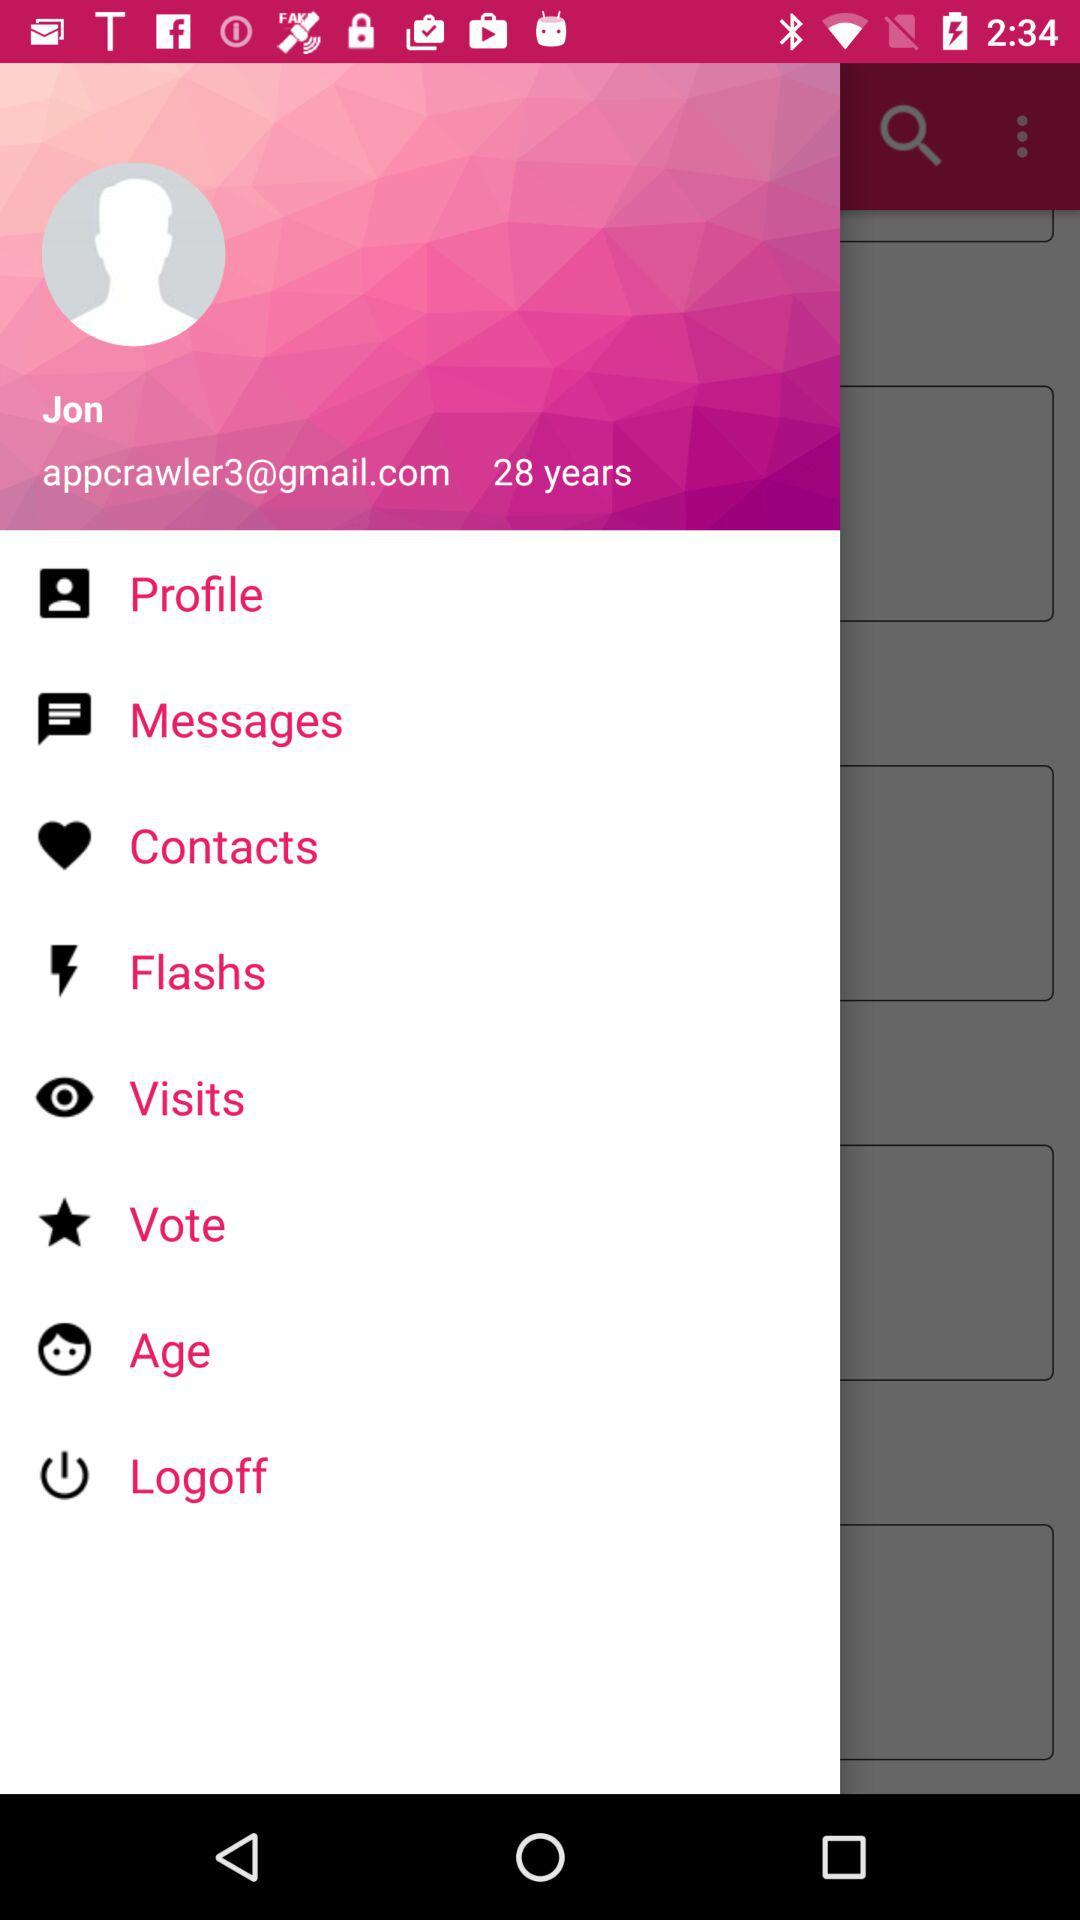What is the user name? The user name is "Jon". 